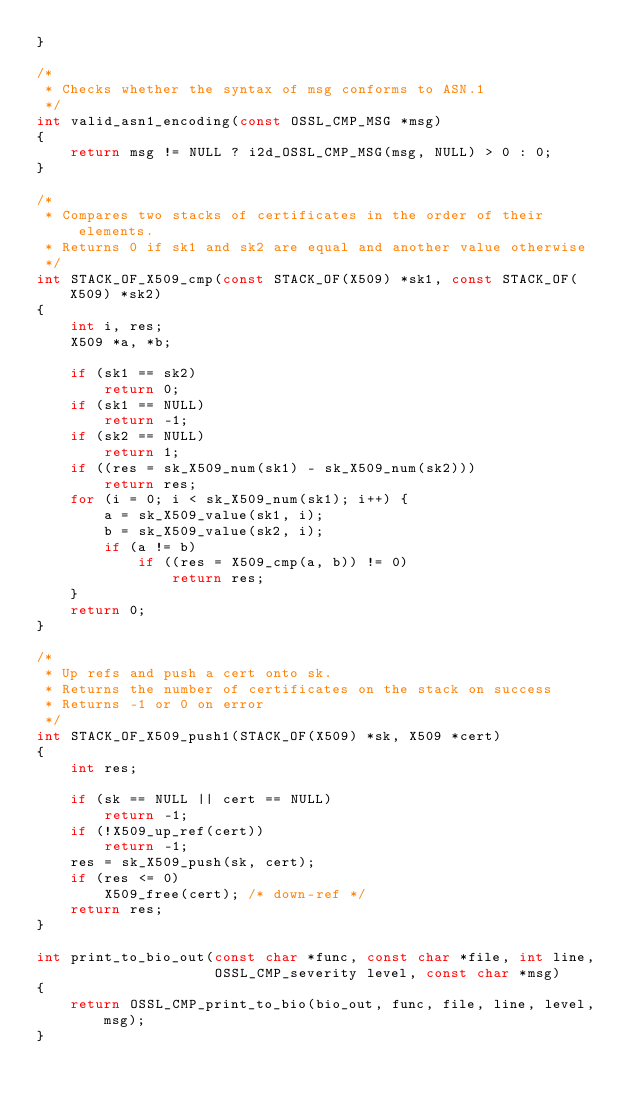<code> <loc_0><loc_0><loc_500><loc_500><_C_>}

/*
 * Checks whether the syntax of msg conforms to ASN.1
 */
int valid_asn1_encoding(const OSSL_CMP_MSG *msg)
{
    return msg != NULL ? i2d_OSSL_CMP_MSG(msg, NULL) > 0 : 0;
}

/*
 * Compares two stacks of certificates in the order of their elements.
 * Returns 0 if sk1 and sk2 are equal and another value otherwise
 */
int STACK_OF_X509_cmp(const STACK_OF(X509) *sk1, const STACK_OF(X509) *sk2)
{
    int i, res;
    X509 *a, *b;

    if (sk1 == sk2)
        return 0;
    if (sk1 == NULL)
        return -1;
    if (sk2 == NULL)
        return 1;
    if ((res = sk_X509_num(sk1) - sk_X509_num(sk2)))
        return res;
    for (i = 0; i < sk_X509_num(sk1); i++) {
        a = sk_X509_value(sk1, i);
        b = sk_X509_value(sk2, i);
        if (a != b)
            if ((res = X509_cmp(a, b)) != 0)
                return res;
    }
    return 0;
}

/*
 * Up refs and push a cert onto sk.
 * Returns the number of certificates on the stack on success
 * Returns -1 or 0 on error
 */
int STACK_OF_X509_push1(STACK_OF(X509) *sk, X509 *cert)
{
    int res;

    if (sk == NULL || cert == NULL)
        return -1;
    if (!X509_up_ref(cert))
        return -1;
    res = sk_X509_push(sk, cert);
    if (res <= 0)
        X509_free(cert); /* down-ref */
    return res;
}

int print_to_bio_out(const char *func, const char *file, int line,
                     OSSL_CMP_severity level, const char *msg)
{
    return OSSL_CMP_print_to_bio(bio_out, func, file, line, level, msg);
}
</code> 